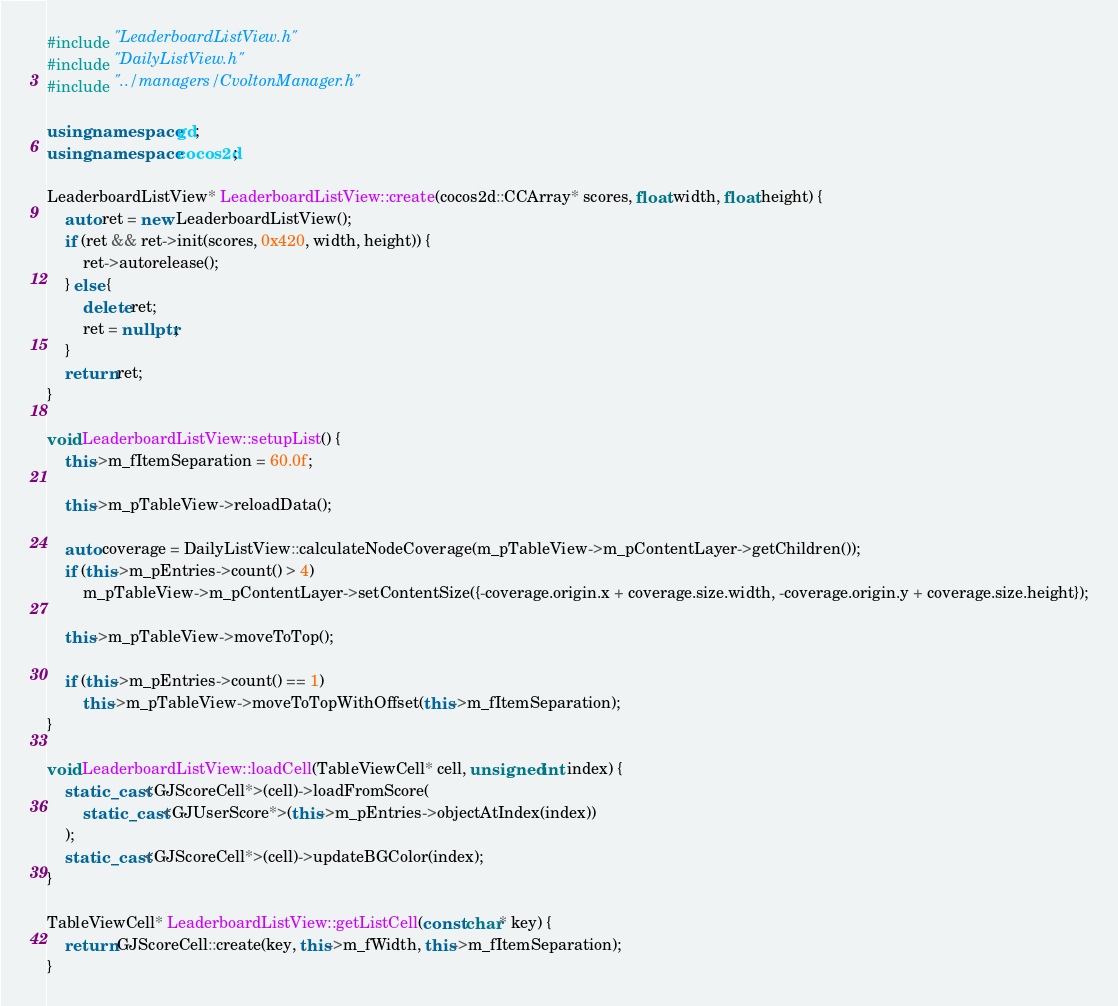<code> <loc_0><loc_0><loc_500><loc_500><_C++_>#include "LeaderboardListView.h"
#include "DailyListView.h"
#include "../managers/CvoltonManager.h"

using namespace gd;
using namespace cocos2d;

LeaderboardListView* LeaderboardListView::create(cocos2d::CCArray* scores, float width, float height) {
    auto ret = new LeaderboardListView();
    if (ret && ret->init(scores, 0x420, width, height)) {
        ret->autorelease();
    } else {
        delete ret;
        ret = nullptr;
    }
    return ret;
}

void LeaderboardListView::setupList() {
    this->m_fItemSeparation = 60.0f;

    this->m_pTableView->reloadData();

    auto coverage = DailyListView::calculateNodeCoverage(m_pTableView->m_pContentLayer->getChildren());
    if (this->m_pEntries->count() > 4)
        m_pTableView->m_pContentLayer->setContentSize({-coverage.origin.x + coverage.size.width, -coverage.origin.y + coverage.size.height});

    this->m_pTableView->moveToTop();

    if (this->m_pEntries->count() == 1)
        this->m_pTableView->moveToTopWithOffset(this->m_fItemSeparation);
}

void LeaderboardListView::loadCell(TableViewCell* cell, unsigned int index) {
    static_cast<GJScoreCell*>(cell)->loadFromScore(
        static_cast<GJUserScore*>(this->m_pEntries->objectAtIndex(index))
    );
    static_cast<GJScoreCell*>(cell)->updateBGColor(index);
}

TableViewCell* LeaderboardListView::getListCell(const char* key) {
    return GJScoreCell::create(key, this->m_fWidth, this->m_fItemSeparation);
}</code> 